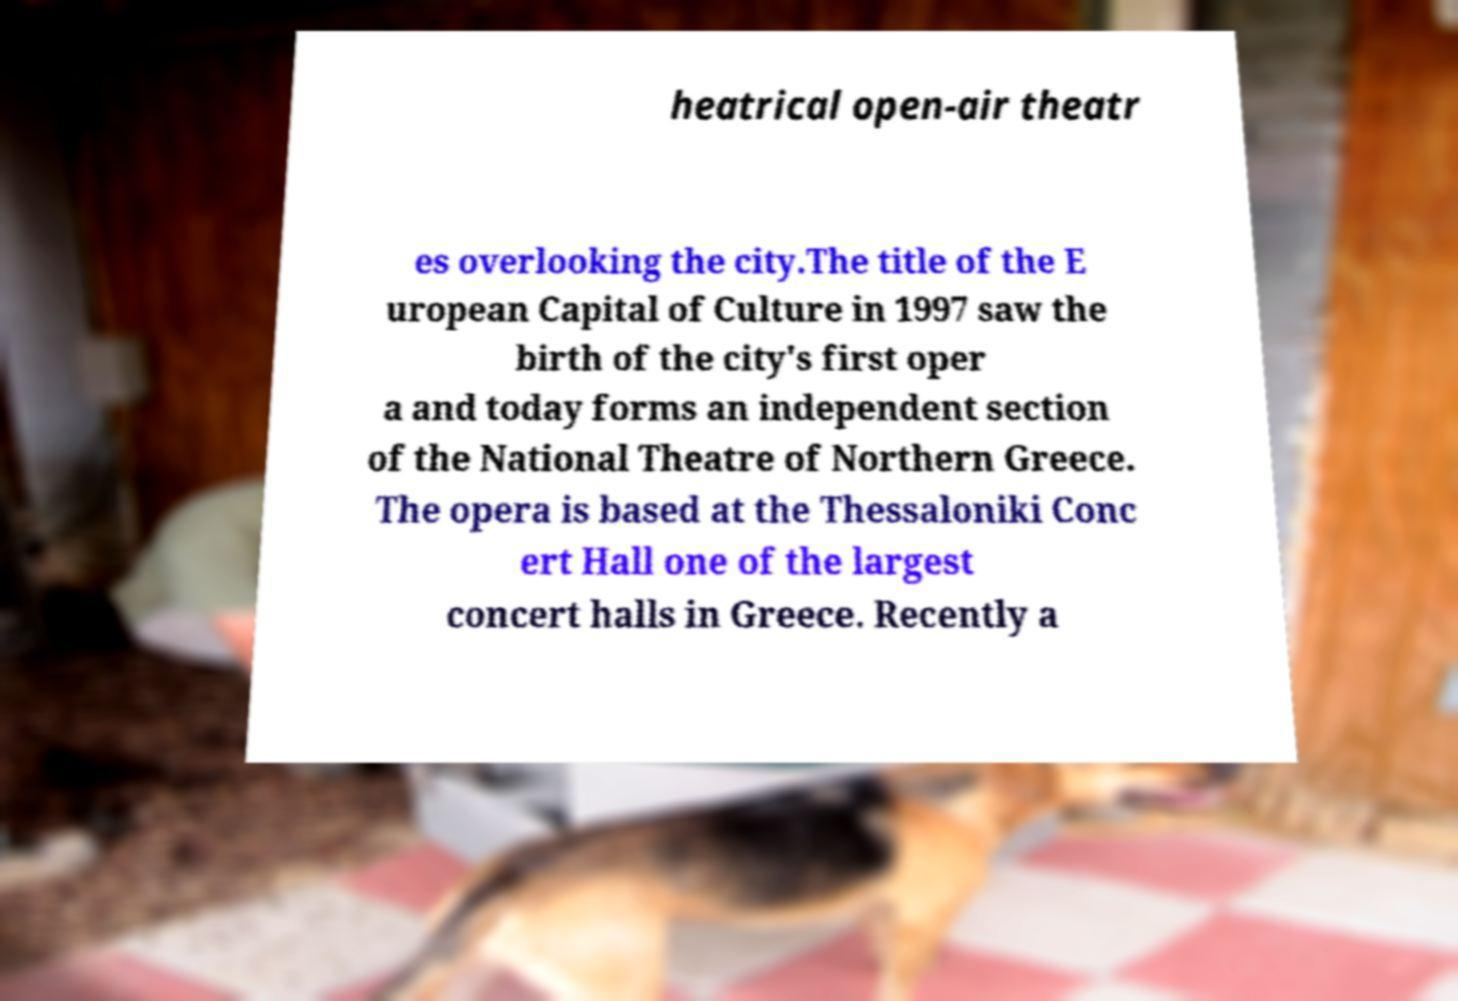Could you extract and type out the text from this image? heatrical open-air theatr es overlooking the city.The title of the E uropean Capital of Culture in 1997 saw the birth of the city's first oper a and today forms an independent section of the National Theatre of Northern Greece. The opera is based at the Thessaloniki Conc ert Hall one of the largest concert halls in Greece. Recently a 